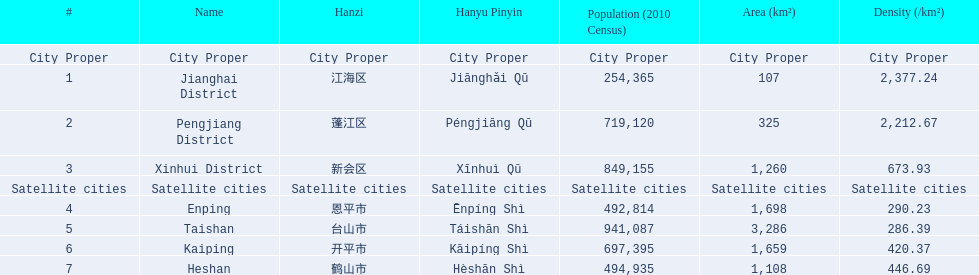What is the most populated district? Taishan. 